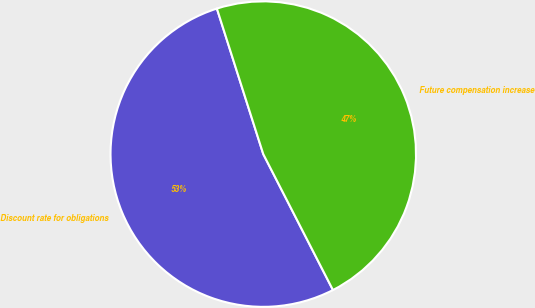Convert chart. <chart><loc_0><loc_0><loc_500><loc_500><pie_chart><fcel>Discount rate for obligations<fcel>Future compensation increase<nl><fcel>52.63%<fcel>47.37%<nl></chart> 